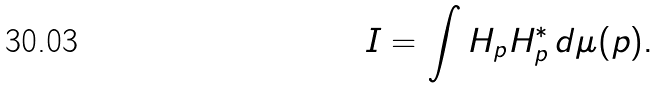<formula> <loc_0><loc_0><loc_500><loc_500>I = \int H _ { p } H _ { p } ^ { * } \, d \mu ( p ) .</formula> 